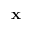Convert formula to latex. <formula><loc_0><loc_0><loc_500><loc_500>x</formula> 